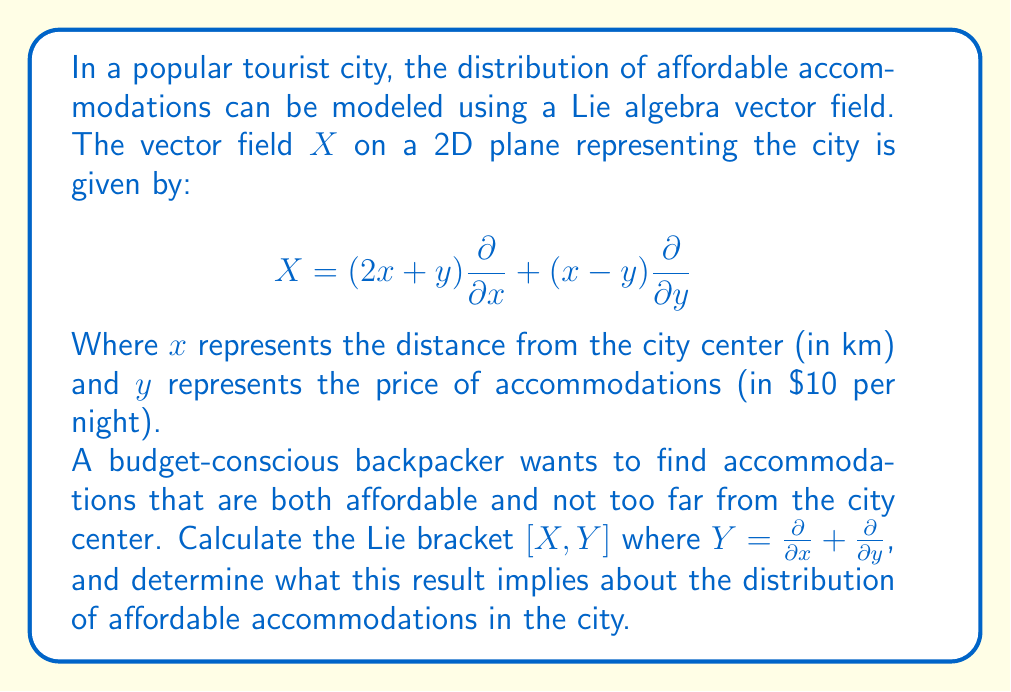Can you solve this math problem? To solve this problem, we need to follow these steps:

1) First, recall the formula for the Lie bracket of two vector fields $X$ and $Y$:

   $$[X, Y] = XY - YX$$

2) We are given:
   $$X = (2x + y)\frac{\partial}{\partial x} + (x - y)\frac{\partial}{\partial y}$$
   $$Y = \frac{\partial}{\partial x} + \frac{\partial}{\partial y}$$

3) Let's calculate $XY$:
   $$XY = (2x + y)\frac{\partial}{\partial x}(\frac{\partial}{\partial x} + \frac{\partial}{\partial y}) + (x - y)\frac{\partial}{\partial y}(\frac{\partial}{\partial x} + \frac{\partial}{\partial y})$$
   $$= (2x + y)\frac{\partial^2}{\partial x^2} + (2x + y)\frac{\partial^2}{\partial x\partial y} + (x - y)\frac{\partial^2}{\partial y\partial x} + (x - y)\frac{\partial^2}{\partial y^2}$$

4) Now, let's calculate $YX$:
   $$YX = \frac{\partial}{\partial x}((2x + y)\frac{\partial}{\partial x} + (x - y)\frac{\partial}{\partial y}) + \frac{\partial}{\partial y}((2x + y)\frac{\partial}{\partial x} + (x - y)\frac{\partial}{\partial y})$$
   $$= 2\frac{\partial}{\partial x} + (2x + y)\frac{\partial^2}{\partial x^2} + \frac{\partial}{\partial x} + (x - y)\frac{\partial^2}{\partial x\partial y} + \frac{\partial}{\partial x} + (2x + y)\frac{\partial^2}{\partial y\partial x} - \frac{\partial}{\partial y} + (x - y)\frac{\partial^2}{\partial y^2}$$

5) Now we can subtract $YX$ from $XY$:
   $$[X, Y] = XY - YX = -2\frac{\partial}{\partial x} - \frac{\partial}{\partial x} + \frac{\partial}{\partial y} = -3\frac{\partial}{\partial x} + \frac{\partial}{\partial y}$$

6) This result implies that as we move through the city following the vector field $X$, the rate of change in the x-direction (distance from city center) is three times greater than the rate of change in the y-direction (price of accommodations), and in the opposite direction.

7) For a budget-conscious backpacker, this means that affordable accommodations (lower y values) tend to be found further from the city center (higher x values). As one moves closer to the city center, prices tend to increase more rapidly than the distance decreases.
Answer: The Lie bracket $[X, Y] = -3\frac{\partial}{\partial x} + \frac{\partial}{\partial y}$. This implies that affordable accommodations are more likely to be found further from the city center, with prices increasing more rapidly than proximity to the center improves as one moves inward. 